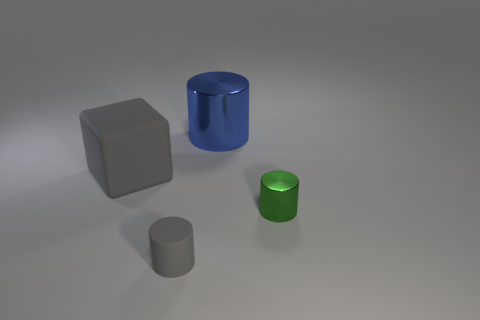There is a large blue cylinder; how many big gray blocks are to the left of it?
Provide a succinct answer. 1. Is the block made of the same material as the cylinder behind the large gray rubber object?
Your answer should be compact. No. What is the size of the green cylinder that is the same material as the blue cylinder?
Provide a succinct answer. Small. Are there more tiny rubber things on the right side of the block than large objects that are to the right of the tiny green shiny thing?
Your response must be concise. Yes. Is there another tiny green object of the same shape as the green object?
Ensure brevity in your answer.  No. There is a cylinder on the right side of the blue metallic cylinder; is it the same size as the matte cube?
Your answer should be compact. No. Are any big gray metal spheres visible?
Provide a succinct answer. No. How many objects are either cylinders that are behind the large rubber object or matte objects?
Give a very brief answer. 3. Is the color of the big metallic object the same as the small object that is on the right side of the gray matte cylinder?
Ensure brevity in your answer.  No. Are there any other cylinders that have the same size as the blue metal cylinder?
Offer a terse response. No. 